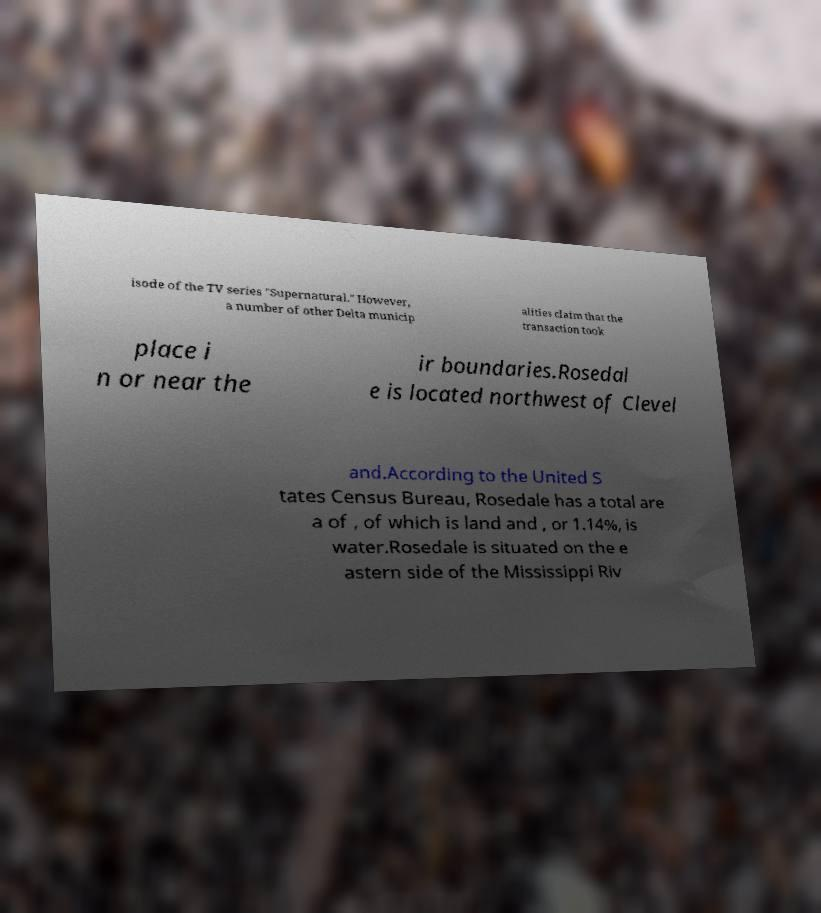Could you extract and type out the text from this image? isode of the TV series "Supernatural." However, a number of other Delta municip alities claim that the transaction took place i n or near the ir boundaries.Rosedal e is located northwest of Clevel and.According to the United S tates Census Bureau, Rosedale has a total are a of , of which is land and , or 1.14%, is water.Rosedale is situated on the e astern side of the Mississippi Riv 